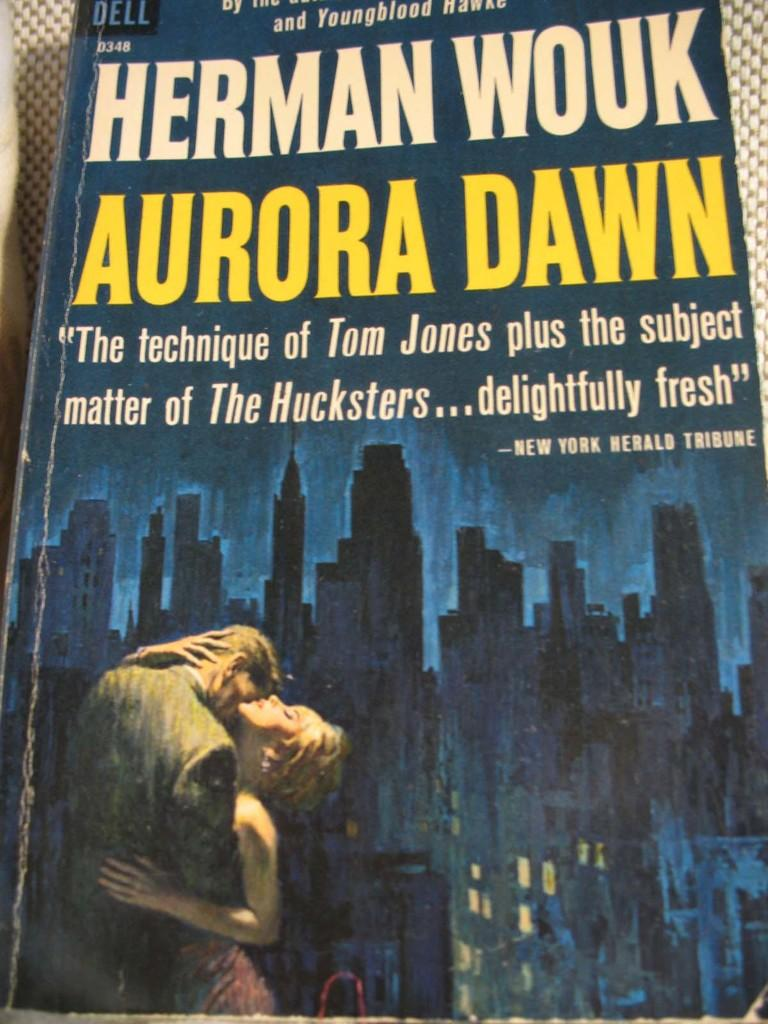<image>
Give a short and clear explanation of the subsequent image. A paperback book is written by Herman Wouk. 